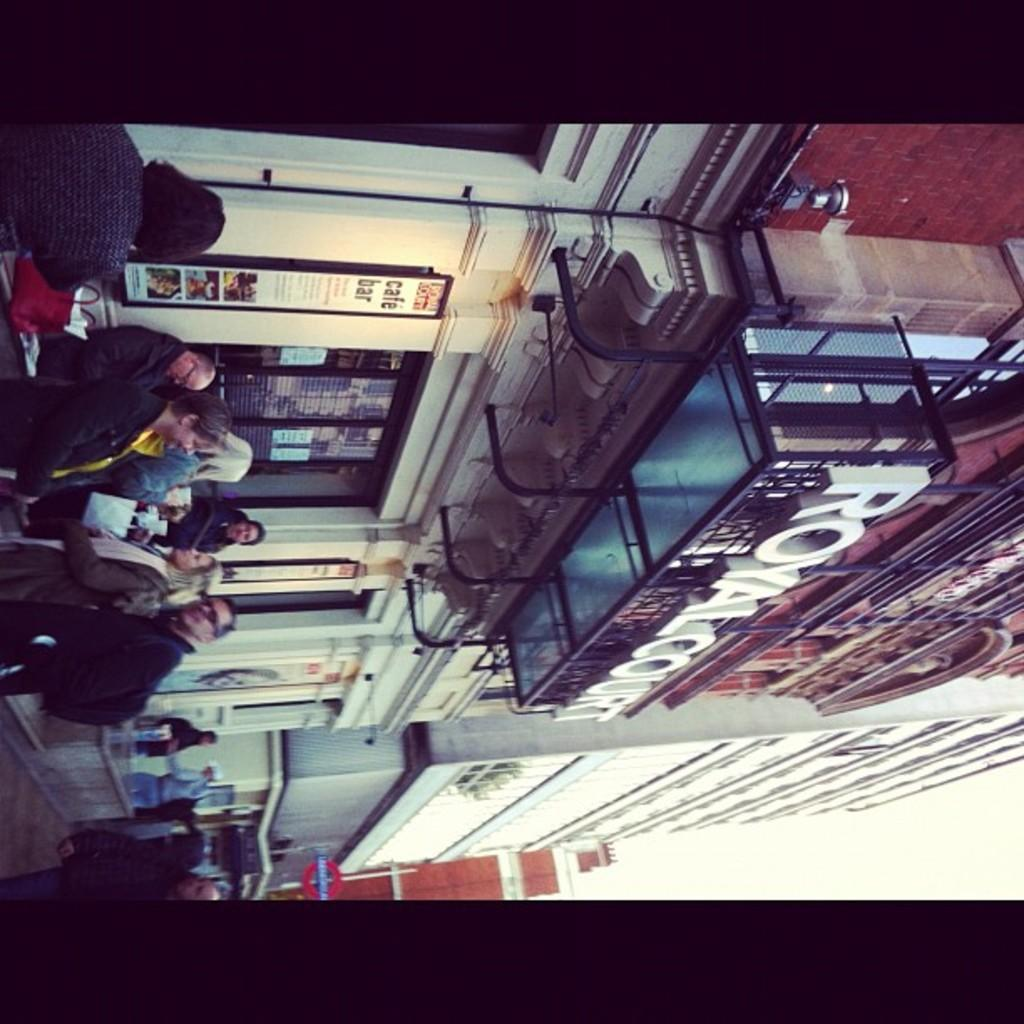What is happening in the image? There are people standing in the image. Where are the people standing? The people are standing in front of buildings. What can be seen in the background of the image? There is sky visible in the background of the image. How many dimes can be seen on the ground in the image? There are no dimes visible on the ground in the image. 